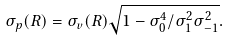<formula> <loc_0><loc_0><loc_500><loc_500>\sigma _ { p } ( R ) = \sigma _ { v } ( R ) \sqrt { 1 - \sigma _ { 0 } ^ { 4 } / \sigma _ { 1 } ^ { 2 } \sigma _ { - 1 } ^ { 2 } } .</formula> 